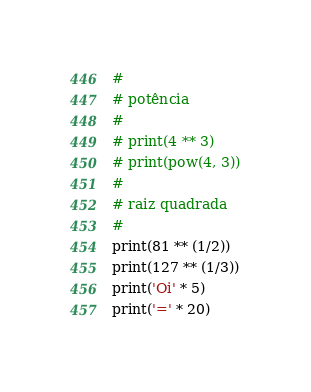<code> <loc_0><loc_0><loc_500><loc_500><_Python_>#
# potência
#
# print(4 ** 3)
# print(pow(4, 3))
#
# raiz quadrada
#
print(81 ** (1/2))
print(127 ** (1/3))
print('Oi' * 5)
print('=' * 20)
</code> 